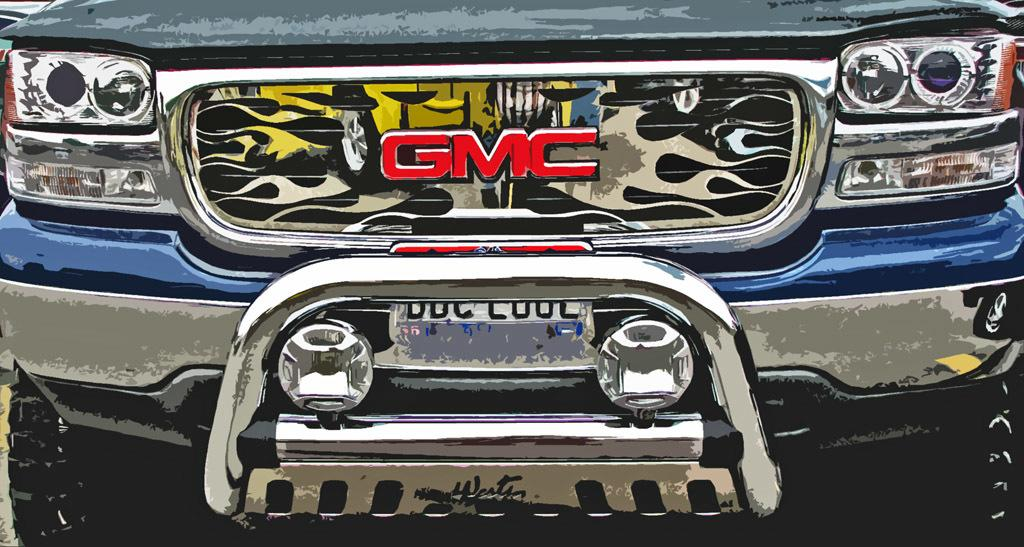What is the main subject of the image? The main subject of the image is a vehicle. What specific features can be seen on the vehicle? The vehicle has headlights and a number plate. Can you tell me how much milk the man is carrying in the image? There is no man or milk present in the image; it only features a vehicle with headlights and a number plate. 